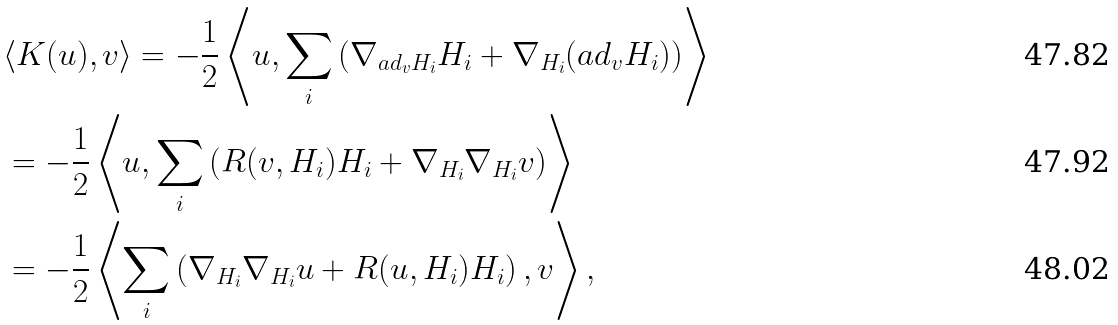<formula> <loc_0><loc_0><loc_500><loc_500>& \langle K ( u ) , v \rangle = - \frac { 1 } { 2 } \left \langle u , \sum _ { i } \left ( \nabla _ { a d _ { v } H _ { i } } H _ { i } + \nabla _ { H _ { i } } ( a d _ { v } H _ { i } ) \right ) \right \rangle \\ & = - \frac { 1 } { 2 } \left \langle u , \sum _ { i } \left ( R ( v , H _ { i } ) H _ { i } + \nabla _ { H _ { i } } \nabla _ { H _ { i } } v \right ) \right \rangle \\ & = - \frac { 1 } { 2 } \left \langle \sum _ { i } \left ( \nabla _ { H _ { i } } \nabla _ { H _ { i } } u + R ( u , H _ { i } ) H _ { i } \right ) , v \right \rangle ,</formula> 